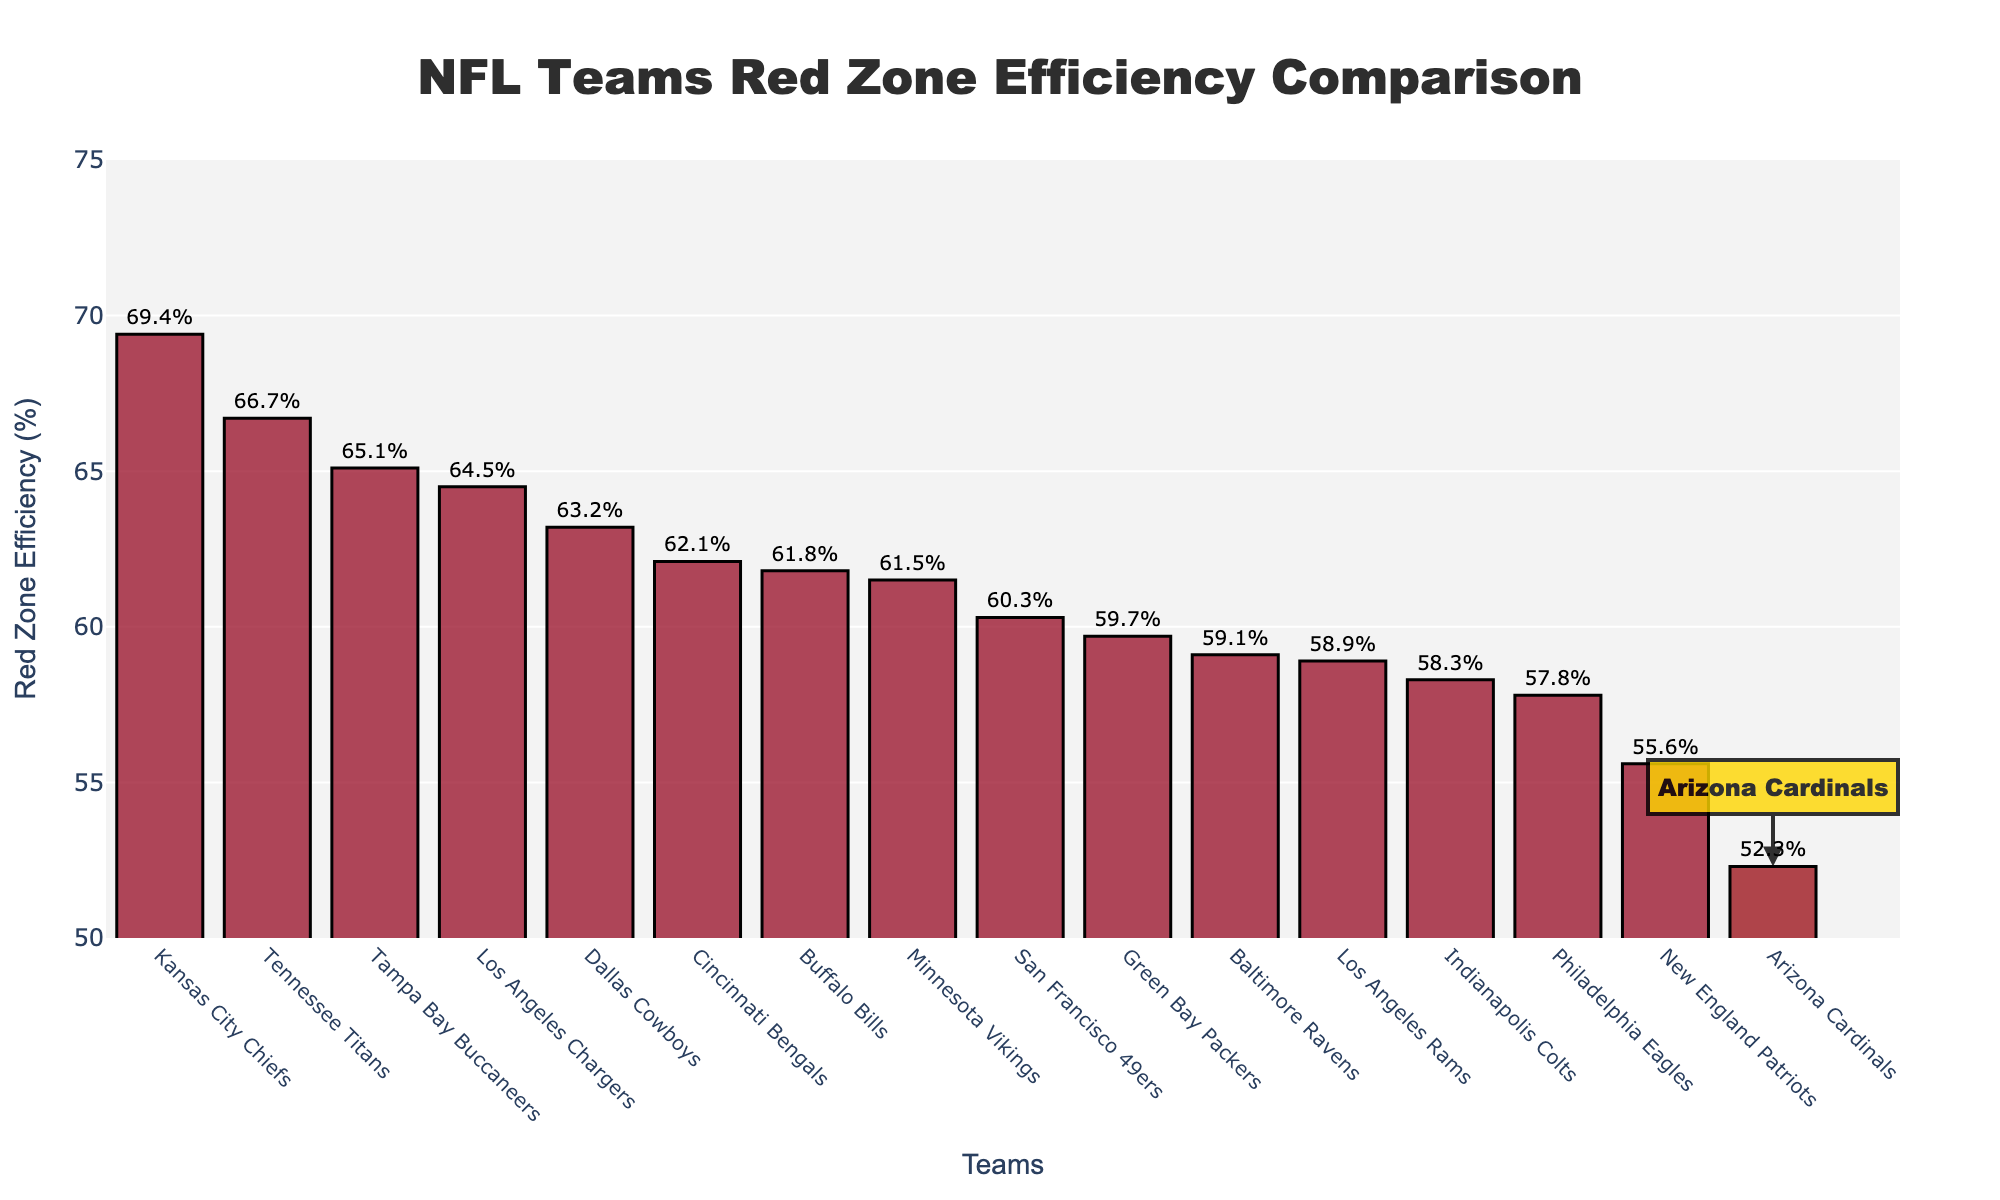How does the Arizona Cardinals' Red Zone Efficiency compare to the Kansas City Chiefs? The Arizona Cardinals have a Red Zone Efficiency of 52.3%, while the Kansas City Chiefs have 69.4%. Comparing these two figures, the Kansas City Chiefs have a significantly higher Red Zone Efficiency.
Answer: The Kansas City Chiefs' efficiency is 17.1% higher than the Cardinals Which team has the highest Red Zone Efficiency, and what is that value? By looking at the bar heights, the Kansas City Chiefs have the highest Red Zone Efficiency. The text on top of the bar indicates their efficiency is 69.4%.
Answer: Kansas City Chiefs with 69.4% What is the difference in Red Zone Efficiency between the Arizona Cardinals and the San Francisco 49ers? The current efficiency for Arizona Cardinals is 52.3%, and for San Francisco 49ers, it is 60.3%. The difference can be found by subtracting the former from the latter: 60.3% - 52.3% = 8%.
Answer: 8% Rank the Arizona Cardinals amongst all NFL teams in terms of Red Zone Efficiency. To determine the rank, identify the number of teams with higher Red Zone Efficiency than the Arizona Cardinals by counting the bars taller than the Cardinals' bar. There are 15 teams total, and 13 have a higher efficiency. The Cardinals therefore rank 14th.
Answer: 14th What color is used to highlight the Arizona Cardinals on the bar chart, and how is this distinction visually indicated? The Arizona Cardinals are highlighted with a gold-colored rectangle around their bar. Additionally, there is a text annotation beside the bar with an arrow pointing to it, both of which are in a similar gold color.
Answer: Gold color with text annotation Which teams have a Red Zone Efficiency between 60% and 65%? By examining the bars within the specified range, the Buffalo Bills (61.8%), the Green Bay Packers (59.7%), the Dallas Cowboys (63.2%), the San Francisco 49ers (60.3%), the Cincinnati Bengals (62.1%), and the Minnesota Vikings (61.5%) fall between 60% and 65%.
Answer: Buffalo Bills, Green Bay Packers, Dallas Cowboys, San Francisco 49ers, Cincinnati Bengals, Minnesota Vikings If the average Red Zone Efficiency of the league is calculated, how does Arizona Cardinals' efficiency compare to this average? To find the average, sum all the percentages and divide by the number of teams. Sum is 928.2%, and there are 16 teams, so average is 928.2 / 16 = 58.0%. Comparing Arizona Cardinals' 52.3% to this average, they are below by 58.0% - 52.3% = 5.7%.
Answer: 5.7% below average Visually, which teams are just below and just above the Arizona Cardinals in Red Zone Efficiency? The team just below the Cardinals (smaller bar just beside) is none since the Cardinals have the lowest Red Zone Efficiency. The team just above them is the New England Patriots with a slightly taller bar at 55.6%.
Answer: New England Patriots (55.6%) What is the median Red Zone Efficiency across the teams? To find the median, order the efficiencies and find the middle value. For 16 teams, the median is the average of the 8th and 9th values. The sorted values are (52.3, 55.6, 57.8, 58.3, 58.9, 59.1, 59.7, 60.3, 61.5, 61.8, 62.1, 63.2, 64.5, 65.1, 66.7, 69.4). Median = (60.3 + 61.5)/2 = 60.9%.
Answer: 60.9% 